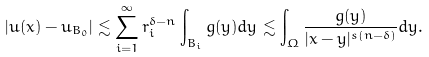Convert formula to latex. <formula><loc_0><loc_0><loc_500><loc_500>| u ( x ) - u _ { B _ { 0 } } | \lesssim \sum _ { i = 1 } ^ { \infty } r _ { i } ^ { \delta - n } \int _ { B _ { i } } g ( y ) d y \lesssim \int _ { \Omega } \frac { g ( y ) } { | x - y | ^ { s ( n - \delta ) } } d y .</formula> 